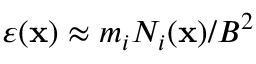<formula> <loc_0><loc_0><loc_500><loc_500>\varepsilon ( { x } ) \approx { m _ { i } N _ { i } ( { x } ) / B ^ { 2 } }</formula> 